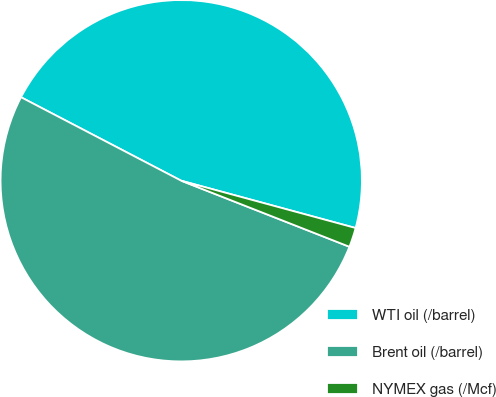<chart> <loc_0><loc_0><loc_500><loc_500><pie_chart><fcel>WTI oil (/barrel)<fcel>Brent oil (/barrel)<fcel>NYMEX gas (/Mcf)<nl><fcel>46.57%<fcel>51.69%<fcel>1.74%<nl></chart> 